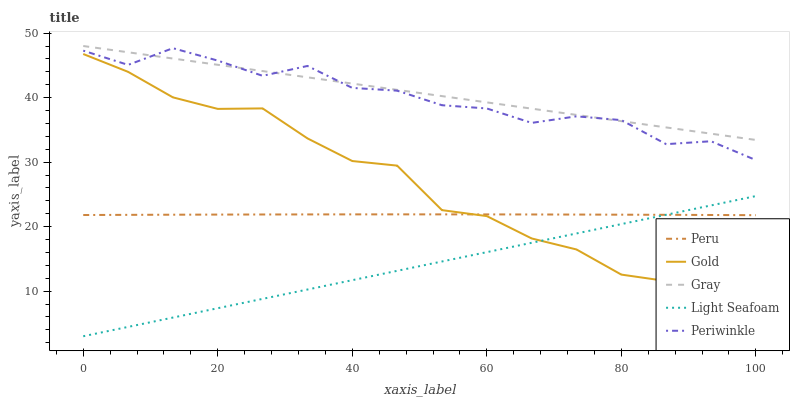Does Light Seafoam have the minimum area under the curve?
Answer yes or no. Yes. Does Gray have the maximum area under the curve?
Answer yes or no. Yes. Does Periwinkle have the minimum area under the curve?
Answer yes or no. No. Does Periwinkle have the maximum area under the curve?
Answer yes or no. No. Is Light Seafoam the smoothest?
Answer yes or no. Yes. Is Gold the roughest?
Answer yes or no. Yes. Is Periwinkle the smoothest?
Answer yes or no. No. Is Periwinkle the roughest?
Answer yes or no. No. Does Light Seafoam have the lowest value?
Answer yes or no. Yes. Does Periwinkle have the lowest value?
Answer yes or no. No. Does Gray have the highest value?
Answer yes or no. Yes. Does Light Seafoam have the highest value?
Answer yes or no. No. Is Peru less than Gray?
Answer yes or no. Yes. Is Gray greater than Light Seafoam?
Answer yes or no. Yes. Does Peru intersect Light Seafoam?
Answer yes or no. Yes. Is Peru less than Light Seafoam?
Answer yes or no. No. Is Peru greater than Light Seafoam?
Answer yes or no. No. Does Peru intersect Gray?
Answer yes or no. No. 